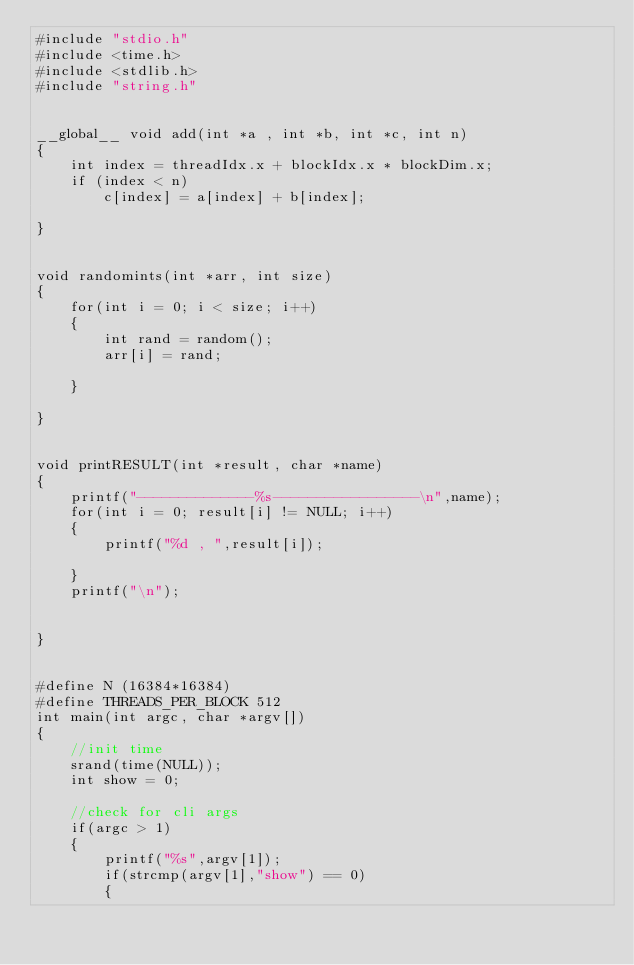<code> <loc_0><loc_0><loc_500><loc_500><_Cuda_>#include "stdio.h"
#include <time.h>
#include <stdlib.h>
#include "string.h"


__global__ void add(int *a , int *b, int *c, int n)
{
    int index = threadIdx.x + blockIdx.x * blockDim.x;
    if (index < n)
        c[index] = a[index] + b[index]; 

}


void randomints(int *arr, int size)
{
    for(int i = 0; i < size; i++)
    {   
        int rand = random();
        arr[i] = rand;
        
    }
    
}


void printRESULT(int *result, char *name)
{   
    printf("--------------%s-----------------\n",name);
    for(int i = 0; result[i] != NULL; i++)
    {
        printf("%d , ",result[i]);

    }
    printf("\n");


}


#define N (16384*16384)
#define THREADS_PER_BLOCK 512
int main(int argc, char *argv[])
{
    //init time
    srand(time(NULL));
    int show = 0;

    //check for cli args
    if(argc > 1)
    {
        printf("%s",argv[1]);
        if(strcmp(argv[1],"show") == 0)
        {</code> 